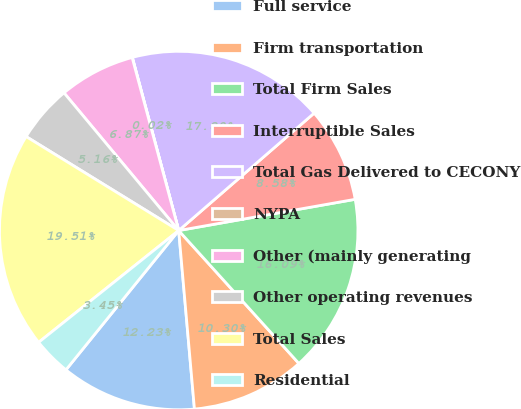Convert chart. <chart><loc_0><loc_0><loc_500><loc_500><pie_chart><fcel>Full service<fcel>Firm transportation<fcel>Total Firm Sales<fcel>Interruptible Sales<fcel>Total Gas Delivered to CECONY<fcel>NYPA<fcel>Other (mainly generating<fcel>Other operating revenues<fcel>Total Sales<fcel>Residential<nl><fcel>12.23%<fcel>10.3%<fcel>16.09%<fcel>8.58%<fcel>17.8%<fcel>0.02%<fcel>6.87%<fcel>5.16%<fcel>19.51%<fcel>3.45%<nl></chart> 